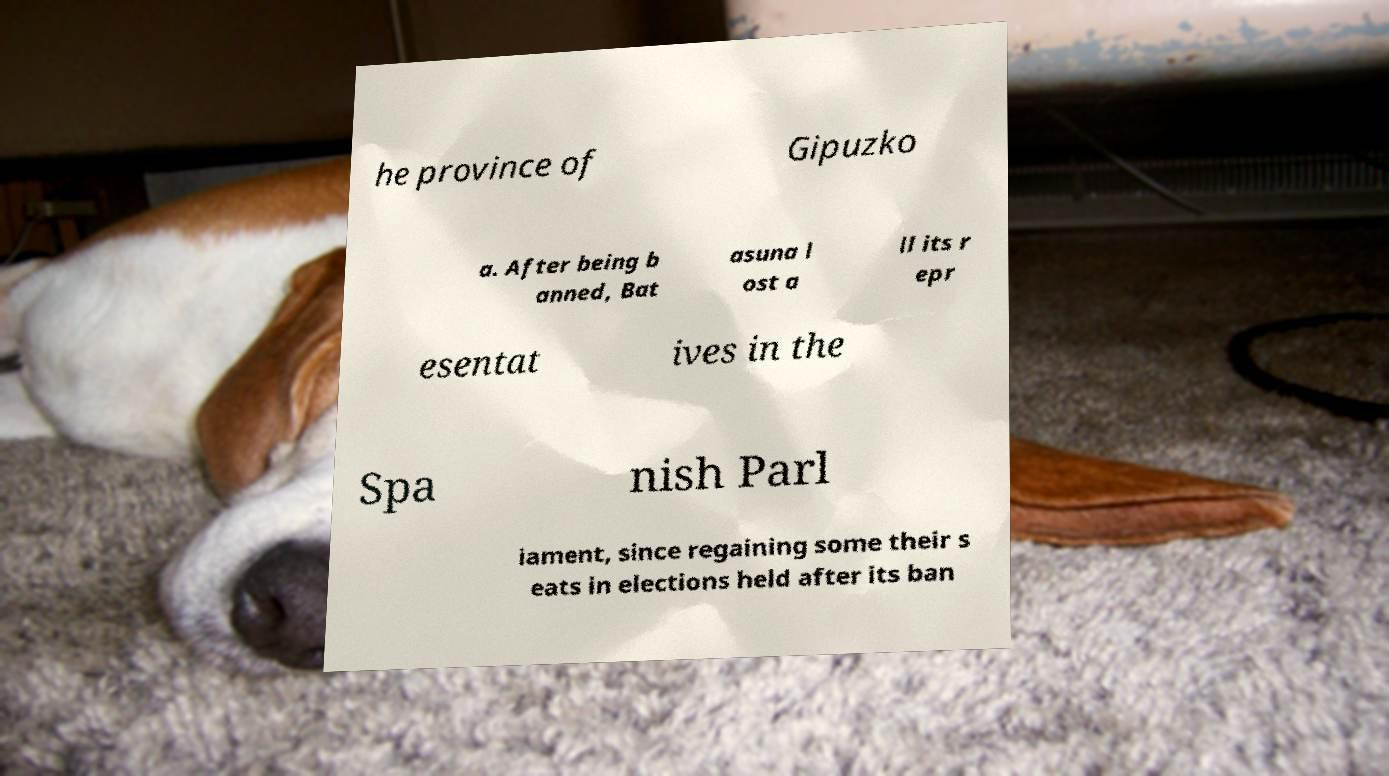Can you accurately transcribe the text from the provided image for me? he province of Gipuzko a. After being b anned, Bat asuna l ost a ll its r epr esentat ives in the Spa nish Parl iament, since regaining some their s eats in elections held after its ban 